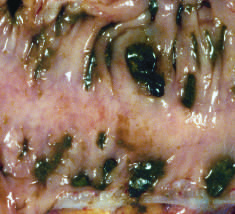what shows regularly spaced stool-filled diverticulae?
Answer the question using a single word or phrase. Gross examination of a resected sigmoid colon 